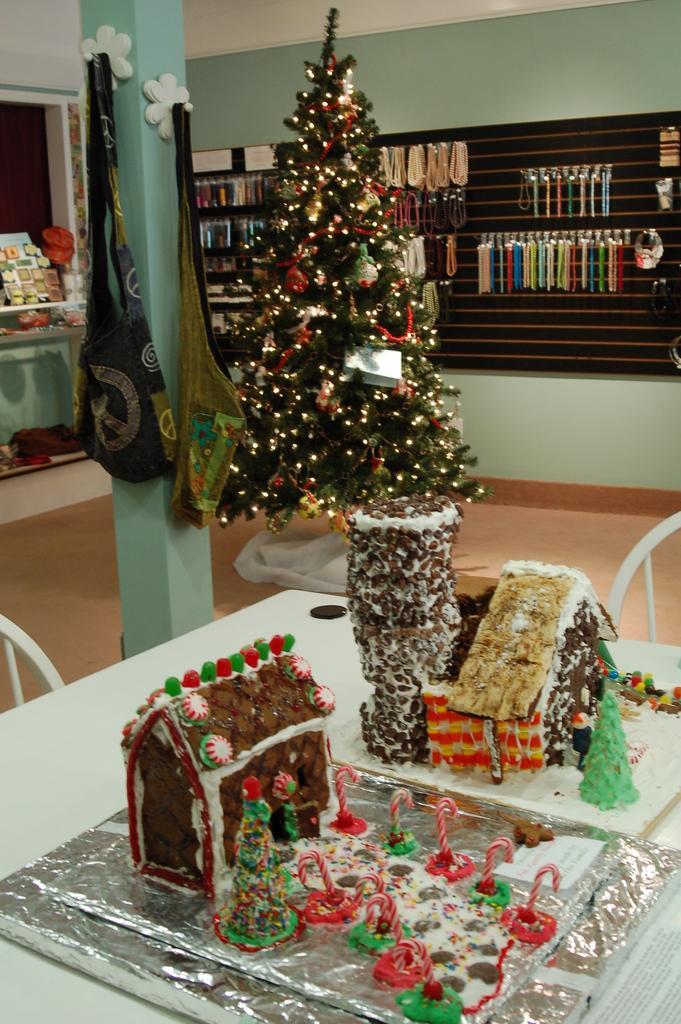Could you give a brief overview of what you see in this image? The picture is from a Christmas celebration. In the foreground of the picture there is a table, on the table there are two huts made of edible food items. In the center of the picture there is Christmas tree. To the left there is a desk, on the desk there are some objects and a window. To the left there is a pillar and bags hanging to it. In the background there is a board, to the board there are many chains. In the center of the background there is a refrigerator. 